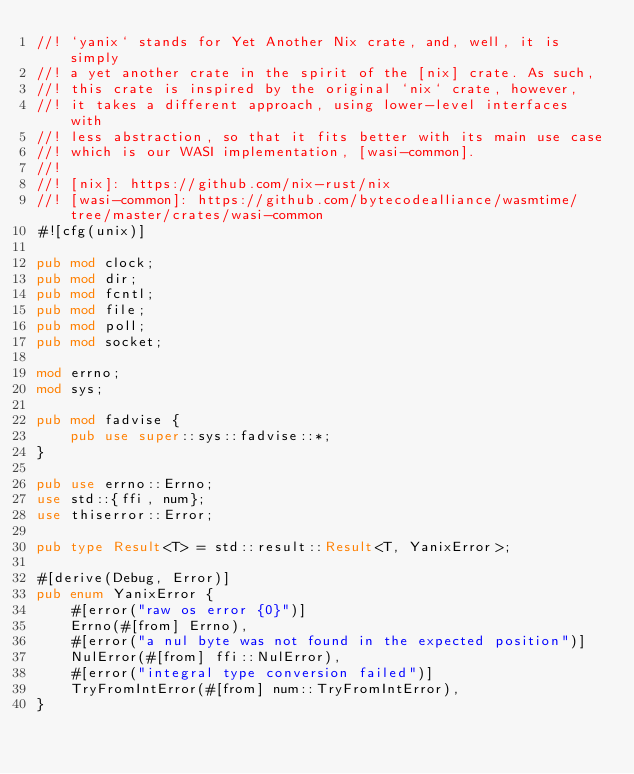Convert code to text. <code><loc_0><loc_0><loc_500><loc_500><_Rust_>//! `yanix` stands for Yet Another Nix crate, and, well, it is simply
//! a yet another crate in the spirit of the [nix] crate. As such,
//! this crate is inspired by the original `nix` crate, however,
//! it takes a different approach, using lower-level interfaces with
//! less abstraction, so that it fits better with its main use case
//! which is our WASI implementation, [wasi-common].
//!
//! [nix]: https://github.com/nix-rust/nix
//! [wasi-common]: https://github.com/bytecodealliance/wasmtime/tree/master/crates/wasi-common
#![cfg(unix)]

pub mod clock;
pub mod dir;
pub mod fcntl;
pub mod file;
pub mod poll;
pub mod socket;

mod errno;
mod sys;

pub mod fadvise {
    pub use super::sys::fadvise::*;
}

pub use errno::Errno;
use std::{ffi, num};
use thiserror::Error;

pub type Result<T> = std::result::Result<T, YanixError>;

#[derive(Debug, Error)]
pub enum YanixError {
    #[error("raw os error {0}")]
    Errno(#[from] Errno),
    #[error("a nul byte was not found in the expected position")]
    NulError(#[from] ffi::NulError),
    #[error("integral type conversion failed")]
    TryFromIntError(#[from] num::TryFromIntError),
}
</code> 